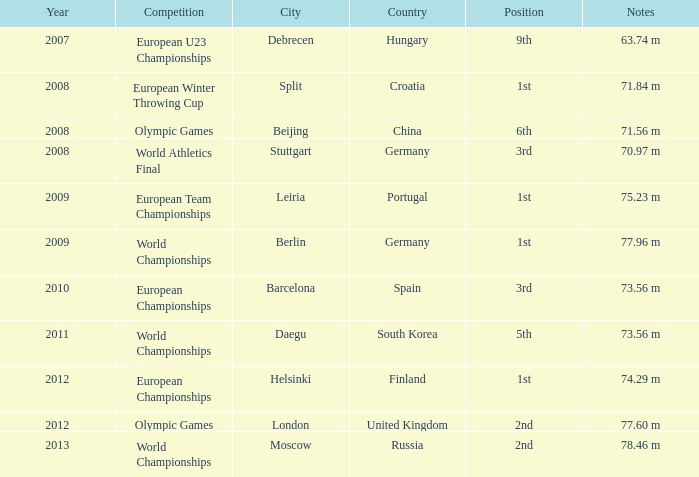What did the notes from 2011 consist of? 73.56 m. 